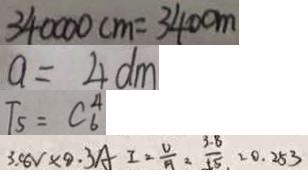Convert formula to latex. <formula><loc_0><loc_0><loc_500><loc_500>3 4 0 0 0 0 c m = 3 4 0 0 m 
 a = 4 d m 
 T _ { 5 } = C _ { 6 } ^ { 4 } 
 3 . 8 V \times 9 . 3 A I = \frac { U } { A } = \frac { 3 . 8 } { 1 5 } = 0 . 2 5 3</formula> 